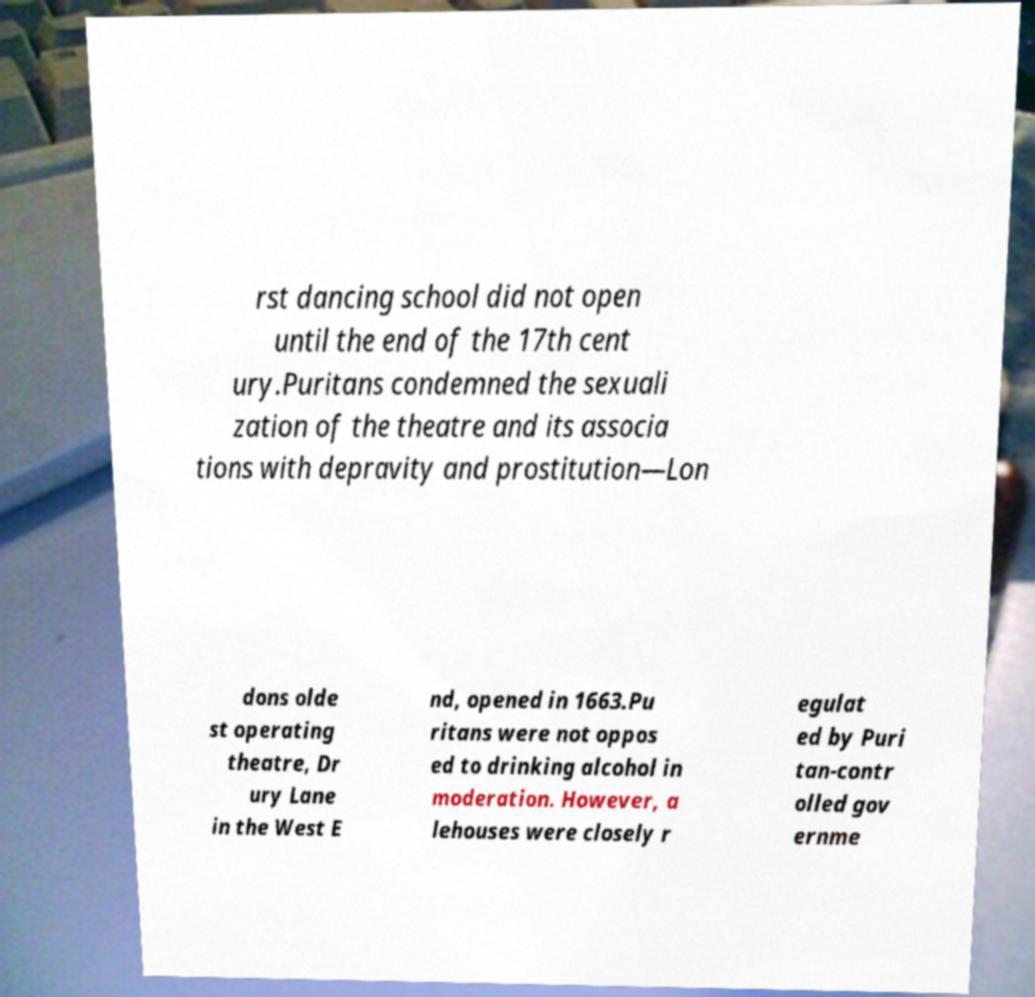Can you read and provide the text displayed in the image?This photo seems to have some interesting text. Can you extract and type it out for me? rst dancing school did not open until the end of the 17th cent ury.Puritans condemned the sexuali zation of the theatre and its associa tions with depravity and prostitution—Lon dons olde st operating theatre, Dr ury Lane in the West E nd, opened in 1663.Pu ritans were not oppos ed to drinking alcohol in moderation. However, a lehouses were closely r egulat ed by Puri tan-contr olled gov ernme 